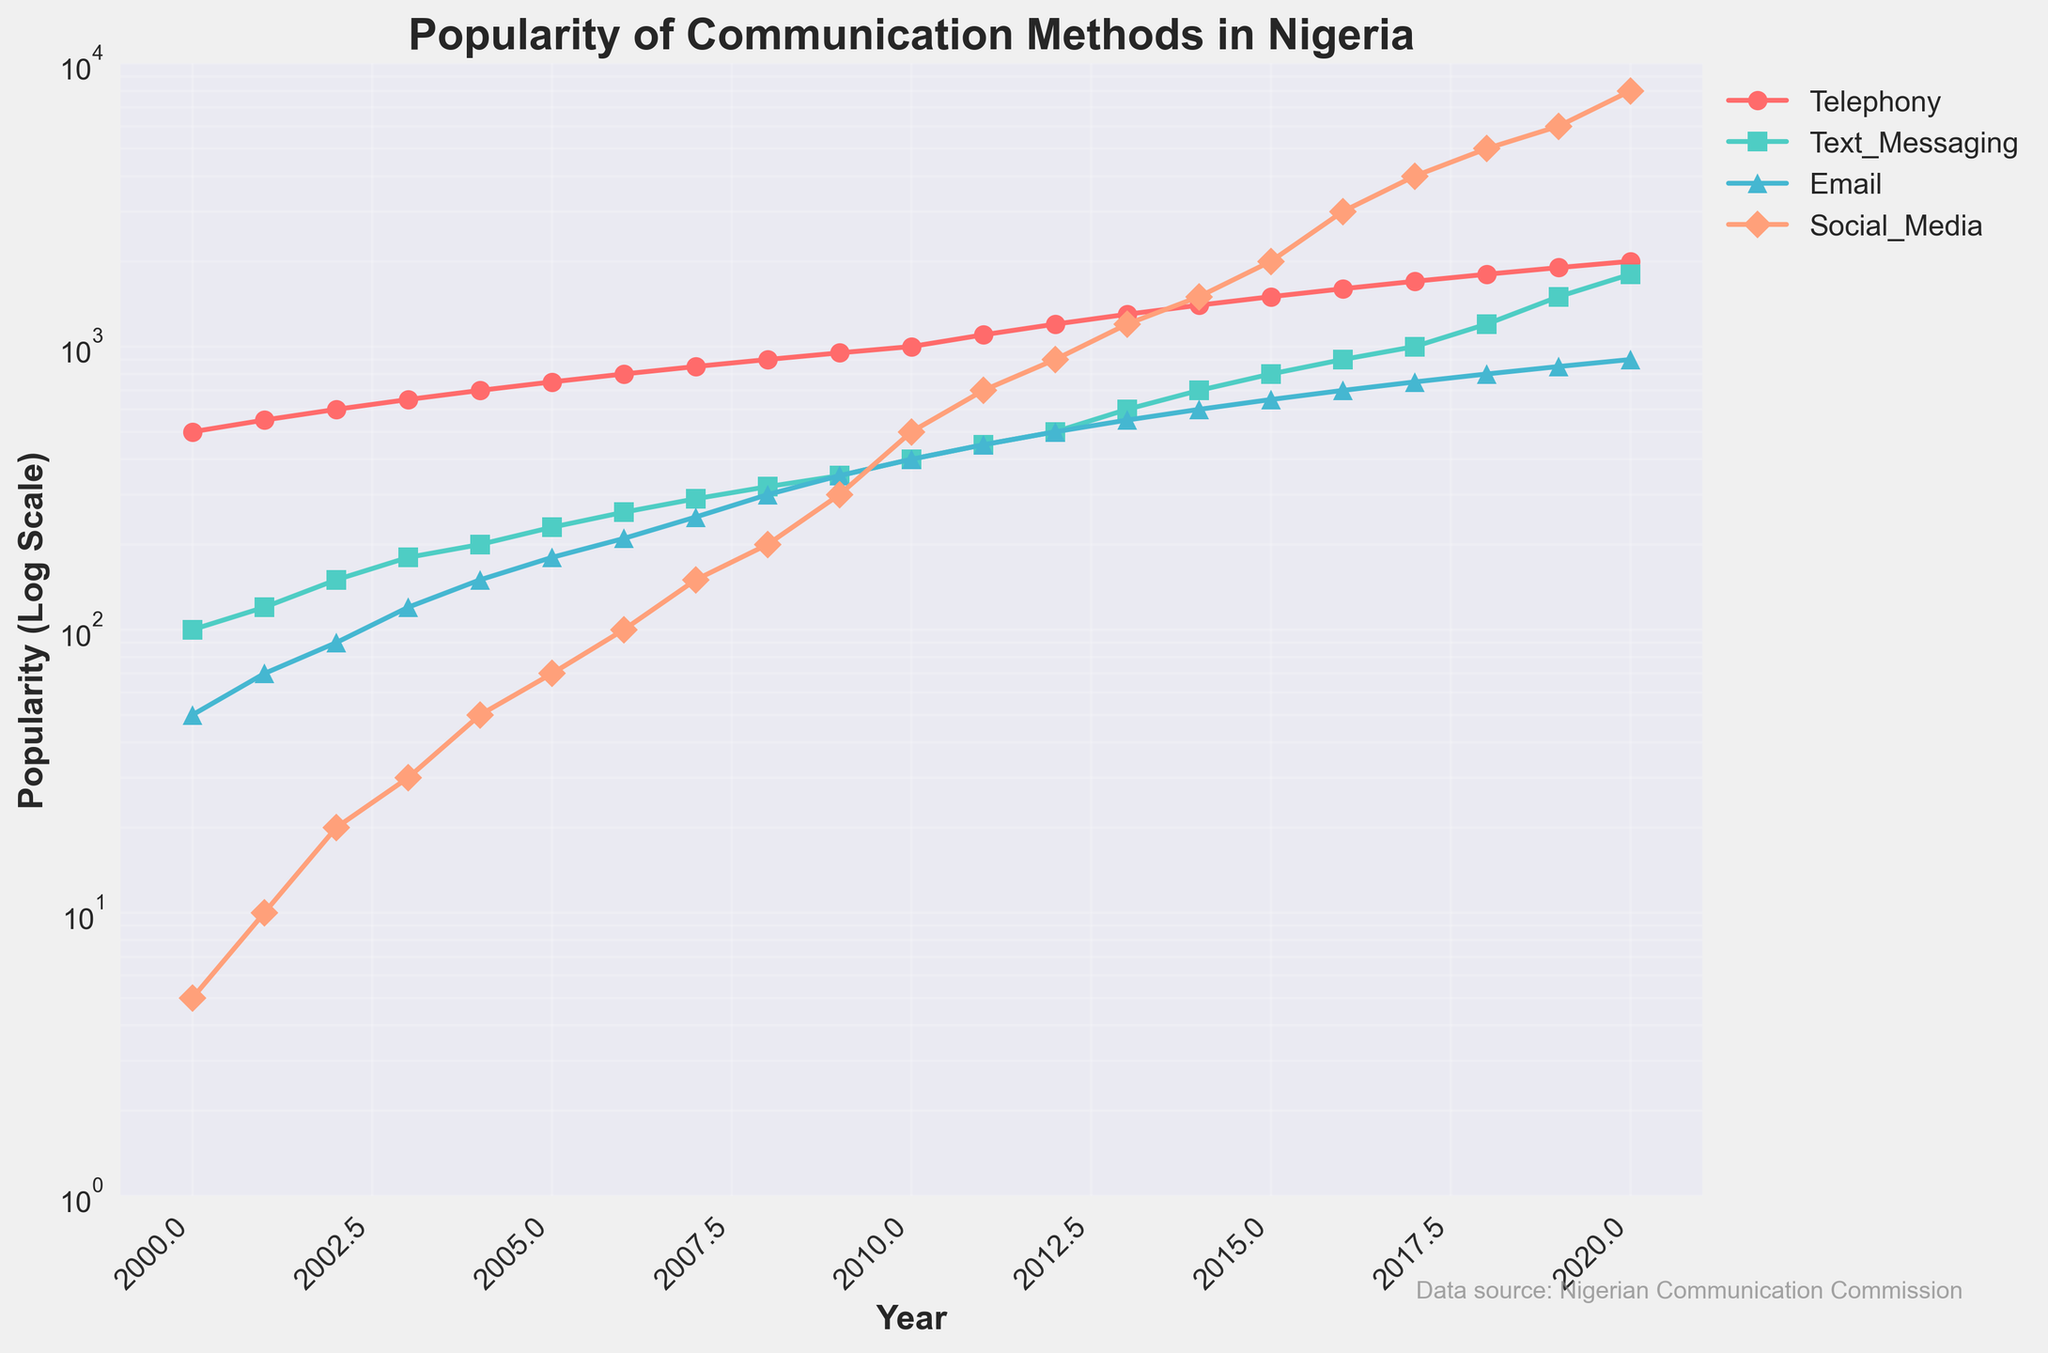Which communication method was the least popular in the year 2000? The plot shows that in the year 2000, Social Media was at the lowest point on the y-axis compared to other methods.
Answer: Social Media How did the popularity of Telephony change from 2000 to 2020? The plot shows an increasing trend in the popularity of Telephony from 500 in 2000 to 2000 in 2020. This is a fourfold increase over the period.
Answer: Increased What is the trend in the popularity of Email from 2005 to 2015? The plot indicates that the popularity of Email increased from 180 in 2005 to 650 in 2015. This shows a consistent upward trend.
Answer: Increasing Which year saw the highest increase in Social Media popularity? The plot shows a significant jump from 3000 in 2016 to 4000 in 2017, the highest increase in a single year.
Answer: 2017 Between Text Messaging and Social Media, which method was more popular in 2012? The plot shows that in 2012, Text Messaging was at 500 while Social Media was at 900, making Social Media more popular.
Answer: Social Media When did Text Messaging first surpass 1000 in popularity? The plot indicates that Text Messaging first surpassed 1000 in popularity in the year 2017.
Answer: 2017 How does the growth rate of Social Media compare to Telephony between 2010 and 2020? For Social Media, the growth is from 500 in 2010 to 8000 in 2020, which is a 16-fold increase. For Telephony, the growth is from 1000 to 2000, a 2-fold increase. Therefore, Social Media's growth rate is much higher.
Answer: Social Media has a faster growth rate Which communication method exhibited the steadiest growth over the entire time period? The plot shows that Telephony's line is the smoothest and most consistent, indicating steady growth over time.
Answer: Telephony At what point does the popularity of Social Media appear to start exceeding all other methods? The plot indicates that Social Media begins to surpass other methods' popularity around 2013 when its curve starts rising more steeply than the others.
Answer: Around 2013 During which period did Telephony's popularity level off? The plot shows that the Telephony's curve becomes nearly horizontal between 2019 and 2020, indicating a leveling off in popularity.
Answer: 2019-2020 